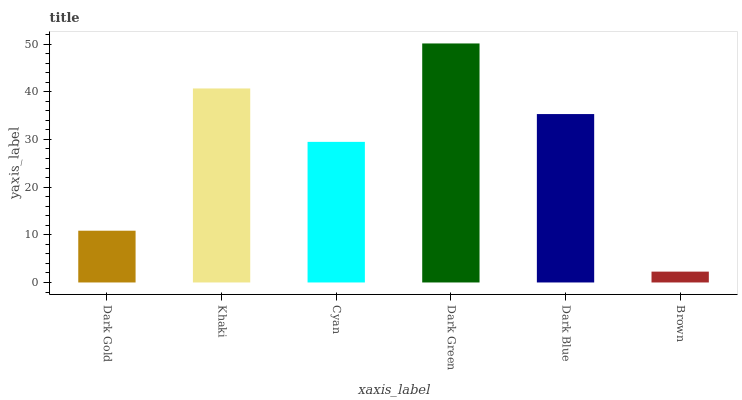Is Brown the minimum?
Answer yes or no. Yes. Is Dark Green the maximum?
Answer yes or no. Yes. Is Khaki the minimum?
Answer yes or no. No. Is Khaki the maximum?
Answer yes or no. No. Is Khaki greater than Dark Gold?
Answer yes or no. Yes. Is Dark Gold less than Khaki?
Answer yes or no. Yes. Is Dark Gold greater than Khaki?
Answer yes or no. No. Is Khaki less than Dark Gold?
Answer yes or no. No. Is Dark Blue the high median?
Answer yes or no. Yes. Is Cyan the low median?
Answer yes or no. Yes. Is Brown the high median?
Answer yes or no. No. Is Brown the low median?
Answer yes or no. No. 